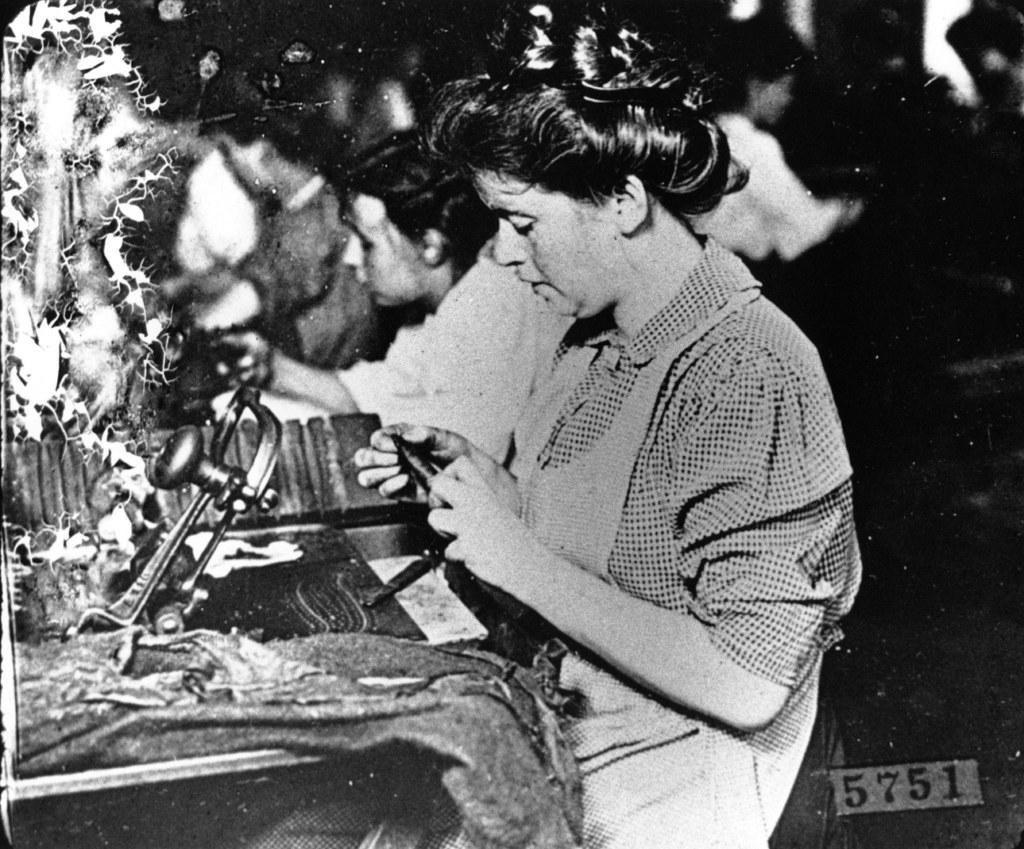What is the color scheme of the image? The image is black and white. What can be seen in the image besides the color scheme? There are people and objects in the image. Can you describe the number plate at the bottom of the image? Yes, there is a number plate at the bottom of the image. What type of toad can be seen hopping in the image? There is no toad present in the image; it is a black and white image with people and objects. Can you describe the ball being used by the people in the image? There is no ball visible in the image; only people, objects, and a number plate are present. 